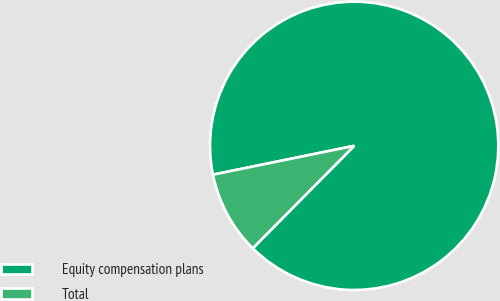<chart> <loc_0><loc_0><loc_500><loc_500><pie_chart><fcel>Equity compensation plans<fcel>Total<nl><fcel>90.63%<fcel>9.37%<nl></chart> 